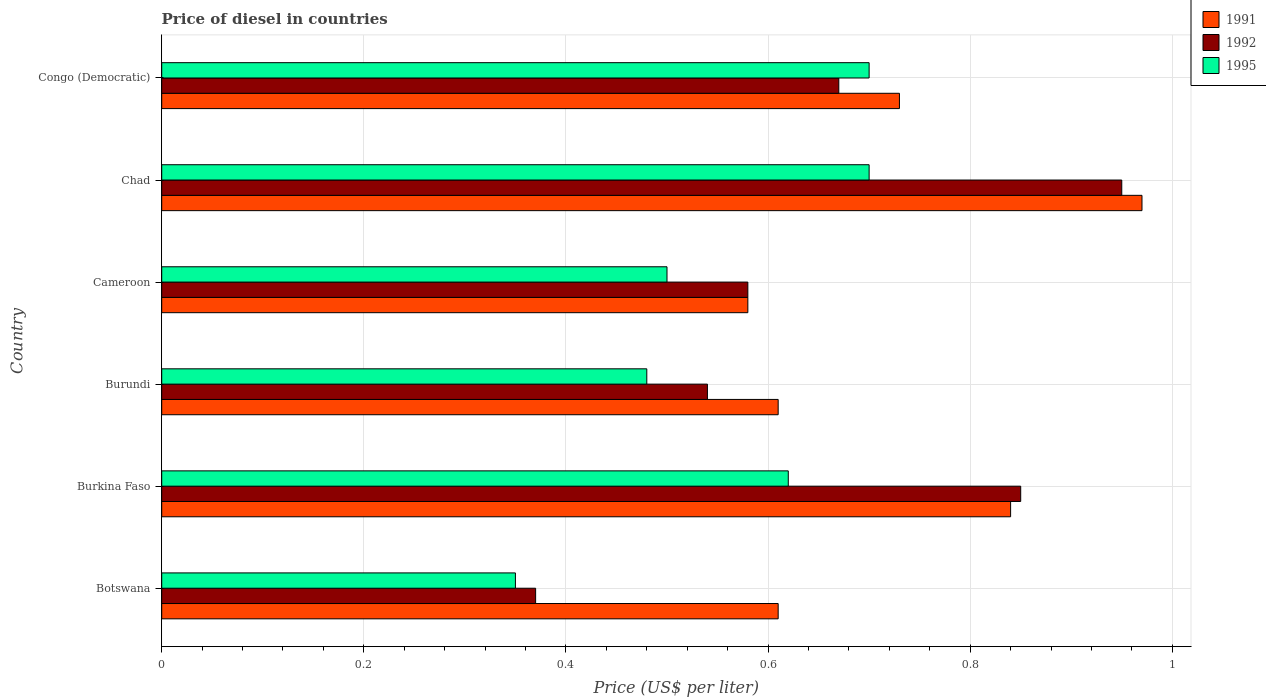How many different coloured bars are there?
Provide a succinct answer. 3. Are the number of bars per tick equal to the number of legend labels?
Provide a succinct answer. Yes. What is the label of the 2nd group of bars from the top?
Your answer should be compact. Chad. What is the price of diesel in 1995 in Burundi?
Provide a succinct answer. 0.48. Across all countries, what is the minimum price of diesel in 1991?
Make the answer very short. 0.58. In which country was the price of diesel in 1991 maximum?
Offer a terse response. Chad. In which country was the price of diesel in 1992 minimum?
Offer a very short reply. Botswana. What is the total price of diesel in 1991 in the graph?
Provide a short and direct response. 4.34. What is the difference between the price of diesel in 1991 in Burkina Faso and that in Burundi?
Make the answer very short. 0.23. What is the difference between the price of diesel in 1995 in Burkina Faso and the price of diesel in 1991 in Burundi?
Your answer should be compact. 0.01. What is the average price of diesel in 1992 per country?
Offer a very short reply. 0.66. What is the difference between the price of diesel in 1995 and price of diesel in 1992 in Chad?
Offer a terse response. -0.25. In how many countries, is the price of diesel in 1995 greater than 0.16 US$?
Your response must be concise. 6. What is the ratio of the price of diesel in 1995 in Burkina Faso to that in Chad?
Your answer should be compact. 0.89. What is the difference between the highest and the second highest price of diesel in 1992?
Your response must be concise. 0.1. What is the difference between the highest and the lowest price of diesel in 1992?
Your answer should be very brief. 0.58. In how many countries, is the price of diesel in 1992 greater than the average price of diesel in 1992 taken over all countries?
Offer a very short reply. 3. What does the 3rd bar from the top in Congo (Democratic) represents?
Provide a succinct answer. 1991. What does the 2nd bar from the bottom in Chad represents?
Offer a very short reply. 1992. Are the values on the major ticks of X-axis written in scientific E-notation?
Give a very brief answer. No. Does the graph contain grids?
Your response must be concise. Yes. How are the legend labels stacked?
Ensure brevity in your answer.  Vertical. What is the title of the graph?
Offer a terse response. Price of diesel in countries. What is the label or title of the X-axis?
Offer a terse response. Price (US$ per liter). What is the Price (US$ per liter) in 1991 in Botswana?
Your answer should be very brief. 0.61. What is the Price (US$ per liter) of 1992 in Botswana?
Make the answer very short. 0.37. What is the Price (US$ per liter) in 1995 in Botswana?
Offer a very short reply. 0.35. What is the Price (US$ per liter) in 1991 in Burkina Faso?
Offer a terse response. 0.84. What is the Price (US$ per liter) of 1995 in Burkina Faso?
Offer a terse response. 0.62. What is the Price (US$ per liter) in 1991 in Burundi?
Your answer should be compact. 0.61. What is the Price (US$ per liter) in 1992 in Burundi?
Make the answer very short. 0.54. What is the Price (US$ per liter) of 1995 in Burundi?
Offer a very short reply. 0.48. What is the Price (US$ per liter) of 1991 in Cameroon?
Your answer should be very brief. 0.58. What is the Price (US$ per liter) of 1992 in Cameroon?
Make the answer very short. 0.58. What is the Price (US$ per liter) of 1995 in Cameroon?
Your answer should be compact. 0.5. What is the Price (US$ per liter) of 1992 in Chad?
Offer a terse response. 0.95. What is the Price (US$ per liter) of 1991 in Congo (Democratic)?
Give a very brief answer. 0.73. What is the Price (US$ per liter) of 1992 in Congo (Democratic)?
Provide a succinct answer. 0.67. What is the Price (US$ per liter) of 1995 in Congo (Democratic)?
Make the answer very short. 0.7. Across all countries, what is the maximum Price (US$ per liter) in 1991?
Make the answer very short. 0.97. Across all countries, what is the maximum Price (US$ per liter) of 1992?
Keep it short and to the point. 0.95. Across all countries, what is the minimum Price (US$ per liter) of 1991?
Offer a very short reply. 0.58. Across all countries, what is the minimum Price (US$ per liter) of 1992?
Make the answer very short. 0.37. What is the total Price (US$ per liter) of 1991 in the graph?
Give a very brief answer. 4.34. What is the total Price (US$ per liter) of 1992 in the graph?
Offer a terse response. 3.96. What is the total Price (US$ per liter) in 1995 in the graph?
Your answer should be compact. 3.35. What is the difference between the Price (US$ per liter) in 1991 in Botswana and that in Burkina Faso?
Provide a succinct answer. -0.23. What is the difference between the Price (US$ per liter) of 1992 in Botswana and that in Burkina Faso?
Your response must be concise. -0.48. What is the difference between the Price (US$ per liter) of 1995 in Botswana and that in Burkina Faso?
Provide a short and direct response. -0.27. What is the difference between the Price (US$ per liter) in 1991 in Botswana and that in Burundi?
Offer a terse response. 0. What is the difference between the Price (US$ per liter) in 1992 in Botswana and that in Burundi?
Your answer should be very brief. -0.17. What is the difference between the Price (US$ per liter) of 1995 in Botswana and that in Burundi?
Your answer should be compact. -0.13. What is the difference between the Price (US$ per liter) of 1991 in Botswana and that in Cameroon?
Give a very brief answer. 0.03. What is the difference between the Price (US$ per liter) in 1992 in Botswana and that in Cameroon?
Offer a very short reply. -0.21. What is the difference between the Price (US$ per liter) in 1991 in Botswana and that in Chad?
Offer a very short reply. -0.36. What is the difference between the Price (US$ per liter) of 1992 in Botswana and that in Chad?
Ensure brevity in your answer.  -0.58. What is the difference between the Price (US$ per liter) of 1995 in Botswana and that in Chad?
Your answer should be compact. -0.35. What is the difference between the Price (US$ per liter) of 1991 in Botswana and that in Congo (Democratic)?
Your response must be concise. -0.12. What is the difference between the Price (US$ per liter) of 1995 in Botswana and that in Congo (Democratic)?
Your answer should be compact. -0.35. What is the difference between the Price (US$ per liter) of 1991 in Burkina Faso and that in Burundi?
Your answer should be very brief. 0.23. What is the difference between the Price (US$ per liter) in 1992 in Burkina Faso and that in Burundi?
Give a very brief answer. 0.31. What is the difference between the Price (US$ per liter) of 1995 in Burkina Faso and that in Burundi?
Make the answer very short. 0.14. What is the difference between the Price (US$ per liter) in 1991 in Burkina Faso and that in Cameroon?
Keep it short and to the point. 0.26. What is the difference between the Price (US$ per liter) of 1992 in Burkina Faso and that in Cameroon?
Provide a succinct answer. 0.27. What is the difference between the Price (US$ per liter) in 1995 in Burkina Faso and that in Cameroon?
Provide a succinct answer. 0.12. What is the difference between the Price (US$ per liter) in 1991 in Burkina Faso and that in Chad?
Give a very brief answer. -0.13. What is the difference between the Price (US$ per liter) in 1995 in Burkina Faso and that in Chad?
Provide a short and direct response. -0.08. What is the difference between the Price (US$ per liter) in 1991 in Burkina Faso and that in Congo (Democratic)?
Keep it short and to the point. 0.11. What is the difference between the Price (US$ per liter) in 1992 in Burkina Faso and that in Congo (Democratic)?
Provide a succinct answer. 0.18. What is the difference between the Price (US$ per liter) of 1995 in Burkina Faso and that in Congo (Democratic)?
Provide a succinct answer. -0.08. What is the difference between the Price (US$ per liter) of 1991 in Burundi and that in Cameroon?
Your answer should be very brief. 0.03. What is the difference between the Price (US$ per liter) in 1992 in Burundi and that in Cameroon?
Offer a terse response. -0.04. What is the difference between the Price (US$ per liter) in 1995 in Burundi and that in Cameroon?
Provide a short and direct response. -0.02. What is the difference between the Price (US$ per liter) in 1991 in Burundi and that in Chad?
Your response must be concise. -0.36. What is the difference between the Price (US$ per liter) in 1992 in Burundi and that in Chad?
Your answer should be compact. -0.41. What is the difference between the Price (US$ per liter) in 1995 in Burundi and that in Chad?
Provide a short and direct response. -0.22. What is the difference between the Price (US$ per liter) in 1991 in Burundi and that in Congo (Democratic)?
Offer a terse response. -0.12. What is the difference between the Price (US$ per liter) in 1992 in Burundi and that in Congo (Democratic)?
Ensure brevity in your answer.  -0.13. What is the difference between the Price (US$ per liter) of 1995 in Burundi and that in Congo (Democratic)?
Make the answer very short. -0.22. What is the difference between the Price (US$ per liter) of 1991 in Cameroon and that in Chad?
Make the answer very short. -0.39. What is the difference between the Price (US$ per liter) of 1992 in Cameroon and that in Chad?
Your answer should be very brief. -0.37. What is the difference between the Price (US$ per liter) in 1991 in Cameroon and that in Congo (Democratic)?
Make the answer very short. -0.15. What is the difference between the Price (US$ per liter) of 1992 in Cameroon and that in Congo (Democratic)?
Provide a succinct answer. -0.09. What is the difference between the Price (US$ per liter) in 1995 in Cameroon and that in Congo (Democratic)?
Provide a succinct answer. -0.2. What is the difference between the Price (US$ per liter) in 1991 in Chad and that in Congo (Democratic)?
Your answer should be compact. 0.24. What is the difference between the Price (US$ per liter) of 1992 in Chad and that in Congo (Democratic)?
Your answer should be very brief. 0.28. What is the difference between the Price (US$ per liter) in 1991 in Botswana and the Price (US$ per liter) in 1992 in Burkina Faso?
Offer a very short reply. -0.24. What is the difference between the Price (US$ per liter) in 1991 in Botswana and the Price (US$ per liter) in 1995 in Burkina Faso?
Give a very brief answer. -0.01. What is the difference between the Price (US$ per liter) of 1992 in Botswana and the Price (US$ per liter) of 1995 in Burkina Faso?
Provide a succinct answer. -0.25. What is the difference between the Price (US$ per liter) in 1991 in Botswana and the Price (US$ per liter) in 1992 in Burundi?
Ensure brevity in your answer.  0.07. What is the difference between the Price (US$ per liter) of 1991 in Botswana and the Price (US$ per liter) of 1995 in Burundi?
Your answer should be compact. 0.13. What is the difference between the Price (US$ per liter) of 1992 in Botswana and the Price (US$ per liter) of 1995 in Burundi?
Offer a very short reply. -0.11. What is the difference between the Price (US$ per liter) of 1991 in Botswana and the Price (US$ per liter) of 1992 in Cameroon?
Keep it short and to the point. 0.03. What is the difference between the Price (US$ per liter) of 1991 in Botswana and the Price (US$ per liter) of 1995 in Cameroon?
Make the answer very short. 0.11. What is the difference between the Price (US$ per liter) of 1992 in Botswana and the Price (US$ per liter) of 1995 in Cameroon?
Provide a short and direct response. -0.13. What is the difference between the Price (US$ per liter) in 1991 in Botswana and the Price (US$ per liter) in 1992 in Chad?
Ensure brevity in your answer.  -0.34. What is the difference between the Price (US$ per liter) of 1991 in Botswana and the Price (US$ per liter) of 1995 in Chad?
Your response must be concise. -0.09. What is the difference between the Price (US$ per liter) in 1992 in Botswana and the Price (US$ per liter) in 1995 in Chad?
Give a very brief answer. -0.33. What is the difference between the Price (US$ per liter) of 1991 in Botswana and the Price (US$ per liter) of 1992 in Congo (Democratic)?
Provide a succinct answer. -0.06. What is the difference between the Price (US$ per liter) of 1991 in Botswana and the Price (US$ per liter) of 1995 in Congo (Democratic)?
Offer a terse response. -0.09. What is the difference between the Price (US$ per liter) in 1992 in Botswana and the Price (US$ per liter) in 1995 in Congo (Democratic)?
Provide a succinct answer. -0.33. What is the difference between the Price (US$ per liter) of 1991 in Burkina Faso and the Price (US$ per liter) of 1992 in Burundi?
Offer a very short reply. 0.3. What is the difference between the Price (US$ per liter) of 1991 in Burkina Faso and the Price (US$ per liter) of 1995 in Burundi?
Offer a very short reply. 0.36. What is the difference between the Price (US$ per liter) in 1992 in Burkina Faso and the Price (US$ per liter) in 1995 in Burundi?
Ensure brevity in your answer.  0.37. What is the difference between the Price (US$ per liter) of 1991 in Burkina Faso and the Price (US$ per liter) of 1992 in Cameroon?
Keep it short and to the point. 0.26. What is the difference between the Price (US$ per liter) in 1991 in Burkina Faso and the Price (US$ per liter) in 1995 in Cameroon?
Keep it short and to the point. 0.34. What is the difference between the Price (US$ per liter) in 1992 in Burkina Faso and the Price (US$ per liter) in 1995 in Cameroon?
Provide a succinct answer. 0.35. What is the difference between the Price (US$ per liter) in 1991 in Burkina Faso and the Price (US$ per liter) in 1992 in Chad?
Make the answer very short. -0.11. What is the difference between the Price (US$ per liter) in 1991 in Burkina Faso and the Price (US$ per liter) in 1995 in Chad?
Provide a short and direct response. 0.14. What is the difference between the Price (US$ per liter) in 1992 in Burkina Faso and the Price (US$ per liter) in 1995 in Chad?
Provide a short and direct response. 0.15. What is the difference between the Price (US$ per liter) of 1991 in Burkina Faso and the Price (US$ per liter) of 1992 in Congo (Democratic)?
Give a very brief answer. 0.17. What is the difference between the Price (US$ per liter) in 1991 in Burkina Faso and the Price (US$ per liter) in 1995 in Congo (Democratic)?
Ensure brevity in your answer.  0.14. What is the difference between the Price (US$ per liter) in 1992 in Burkina Faso and the Price (US$ per liter) in 1995 in Congo (Democratic)?
Your answer should be compact. 0.15. What is the difference between the Price (US$ per liter) of 1991 in Burundi and the Price (US$ per liter) of 1995 in Cameroon?
Offer a very short reply. 0.11. What is the difference between the Price (US$ per liter) in 1991 in Burundi and the Price (US$ per liter) in 1992 in Chad?
Keep it short and to the point. -0.34. What is the difference between the Price (US$ per liter) in 1991 in Burundi and the Price (US$ per liter) in 1995 in Chad?
Keep it short and to the point. -0.09. What is the difference between the Price (US$ per liter) of 1992 in Burundi and the Price (US$ per liter) of 1995 in Chad?
Provide a short and direct response. -0.16. What is the difference between the Price (US$ per liter) in 1991 in Burundi and the Price (US$ per liter) in 1992 in Congo (Democratic)?
Ensure brevity in your answer.  -0.06. What is the difference between the Price (US$ per liter) in 1991 in Burundi and the Price (US$ per liter) in 1995 in Congo (Democratic)?
Your response must be concise. -0.09. What is the difference between the Price (US$ per liter) of 1992 in Burundi and the Price (US$ per liter) of 1995 in Congo (Democratic)?
Provide a succinct answer. -0.16. What is the difference between the Price (US$ per liter) of 1991 in Cameroon and the Price (US$ per liter) of 1992 in Chad?
Offer a very short reply. -0.37. What is the difference between the Price (US$ per liter) in 1991 in Cameroon and the Price (US$ per liter) in 1995 in Chad?
Offer a very short reply. -0.12. What is the difference between the Price (US$ per liter) of 1992 in Cameroon and the Price (US$ per liter) of 1995 in Chad?
Provide a short and direct response. -0.12. What is the difference between the Price (US$ per liter) of 1991 in Cameroon and the Price (US$ per liter) of 1992 in Congo (Democratic)?
Keep it short and to the point. -0.09. What is the difference between the Price (US$ per liter) in 1991 in Cameroon and the Price (US$ per liter) in 1995 in Congo (Democratic)?
Your answer should be very brief. -0.12. What is the difference between the Price (US$ per liter) of 1992 in Cameroon and the Price (US$ per liter) of 1995 in Congo (Democratic)?
Your response must be concise. -0.12. What is the difference between the Price (US$ per liter) in 1991 in Chad and the Price (US$ per liter) in 1992 in Congo (Democratic)?
Provide a succinct answer. 0.3. What is the difference between the Price (US$ per liter) of 1991 in Chad and the Price (US$ per liter) of 1995 in Congo (Democratic)?
Offer a very short reply. 0.27. What is the difference between the Price (US$ per liter) in 1992 in Chad and the Price (US$ per liter) in 1995 in Congo (Democratic)?
Ensure brevity in your answer.  0.25. What is the average Price (US$ per liter) of 1991 per country?
Keep it short and to the point. 0.72. What is the average Price (US$ per liter) in 1992 per country?
Your answer should be compact. 0.66. What is the average Price (US$ per liter) in 1995 per country?
Offer a very short reply. 0.56. What is the difference between the Price (US$ per liter) in 1991 and Price (US$ per liter) in 1992 in Botswana?
Ensure brevity in your answer.  0.24. What is the difference between the Price (US$ per liter) of 1991 and Price (US$ per liter) of 1995 in Botswana?
Make the answer very short. 0.26. What is the difference between the Price (US$ per liter) of 1992 and Price (US$ per liter) of 1995 in Botswana?
Offer a terse response. 0.02. What is the difference between the Price (US$ per liter) of 1991 and Price (US$ per liter) of 1992 in Burkina Faso?
Your answer should be compact. -0.01. What is the difference between the Price (US$ per liter) of 1991 and Price (US$ per liter) of 1995 in Burkina Faso?
Ensure brevity in your answer.  0.22. What is the difference between the Price (US$ per liter) in 1992 and Price (US$ per liter) in 1995 in Burkina Faso?
Your answer should be compact. 0.23. What is the difference between the Price (US$ per liter) of 1991 and Price (US$ per liter) of 1992 in Burundi?
Make the answer very short. 0.07. What is the difference between the Price (US$ per liter) in 1991 and Price (US$ per liter) in 1995 in Burundi?
Your answer should be compact. 0.13. What is the difference between the Price (US$ per liter) of 1992 and Price (US$ per liter) of 1995 in Burundi?
Your response must be concise. 0.06. What is the difference between the Price (US$ per liter) of 1991 and Price (US$ per liter) of 1992 in Cameroon?
Ensure brevity in your answer.  0. What is the difference between the Price (US$ per liter) in 1991 and Price (US$ per liter) in 1995 in Cameroon?
Give a very brief answer. 0.08. What is the difference between the Price (US$ per liter) in 1992 and Price (US$ per liter) in 1995 in Cameroon?
Offer a very short reply. 0.08. What is the difference between the Price (US$ per liter) in 1991 and Price (US$ per liter) in 1992 in Chad?
Offer a very short reply. 0.02. What is the difference between the Price (US$ per liter) of 1991 and Price (US$ per liter) of 1995 in Chad?
Make the answer very short. 0.27. What is the difference between the Price (US$ per liter) of 1991 and Price (US$ per liter) of 1992 in Congo (Democratic)?
Your answer should be very brief. 0.06. What is the difference between the Price (US$ per liter) of 1992 and Price (US$ per liter) of 1995 in Congo (Democratic)?
Offer a terse response. -0.03. What is the ratio of the Price (US$ per liter) of 1991 in Botswana to that in Burkina Faso?
Give a very brief answer. 0.73. What is the ratio of the Price (US$ per liter) in 1992 in Botswana to that in Burkina Faso?
Offer a terse response. 0.44. What is the ratio of the Price (US$ per liter) of 1995 in Botswana to that in Burkina Faso?
Provide a short and direct response. 0.56. What is the ratio of the Price (US$ per liter) in 1991 in Botswana to that in Burundi?
Keep it short and to the point. 1. What is the ratio of the Price (US$ per liter) of 1992 in Botswana to that in Burundi?
Your response must be concise. 0.69. What is the ratio of the Price (US$ per liter) of 1995 in Botswana to that in Burundi?
Ensure brevity in your answer.  0.73. What is the ratio of the Price (US$ per liter) of 1991 in Botswana to that in Cameroon?
Provide a succinct answer. 1.05. What is the ratio of the Price (US$ per liter) of 1992 in Botswana to that in Cameroon?
Offer a terse response. 0.64. What is the ratio of the Price (US$ per liter) in 1991 in Botswana to that in Chad?
Give a very brief answer. 0.63. What is the ratio of the Price (US$ per liter) of 1992 in Botswana to that in Chad?
Provide a succinct answer. 0.39. What is the ratio of the Price (US$ per liter) in 1995 in Botswana to that in Chad?
Offer a terse response. 0.5. What is the ratio of the Price (US$ per liter) in 1991 in Botswana to that in Congo (Democratic)?
Make the answer very short. 0.84. What is the ratio of the Price (US$ per liter) in 1992 in Botswana to that in Congo (Democratic)?
Keep it short and to the point. 0.55. What is the ratio of the Price (US$ per liter) of 1995 in Botswana to that in Congo (Democratic)?
Your answer should be very brief. 0.5. What is the ratio of the Price (US$ per liter) in 1991 in Burkina Faso to that in Burundi?
Provide a succinct answer. 1.38. What is the ratio of the Price (US$ per liter) of 1992 in Burkina Faso to that in Burundi?
Make the answer very short. 1.57. What is the ratio of the Price (US$ per liter) of 1995 in Burkina Faso to that in Burundi?
Keep it short and to the point. 1.29. What is the ratio of the Price (US$ per liter) of 1991 in Burkina Faso to that in Cameroon?
Provide a succinct answer. 1.45. What is the ratio of the Price (US$ per liter) in 1992 in Burkina Faso to that in Cameroon?
Ensure brevity in your answer.  1.47. What is the ratio of the Price (US$ per liter) in 1995 in Burkina Faso to that in Cameroon?
Provide a short and direct response. 1.24. What is the ratio of the Price (US$ per liter) in 1991 in Burkina Faso to that in Chad?
Your answer should be compact. 0.87. What is the ratio of the Price (US$ per liter) in 1992 in Burkina Faso to that in Chad?
Provide a short and direct response. 0.89. What is the ratio of the Price (US$ per liter) of 1995 in Burkina Faso to that in Chad?
Provide a short and direct response. 0.89. What is the ratio of the Price (US$ per liter) in 1991 in Burkina Faso to that in Congo (Democratic)?
Offer a very short reply. 1.15. What is the ratio of the Price (US$ per liter) in 1992 in Burkina Faso to that in Congo (Democratic)?
Provide a short and direct response. 1.27. What is the ratio of the Price (US$ per liter) in 1995 in Burkina Faso to that in Congo (Democratic)?
Provide a short and direct response. 0.89. What is the ratio of the Price (US$ per liter) in 1991 in Burundi to that in Cameroon?
Your answer should be compact. 1.05. What is the ratio of the Price (US$ per liter) in 1991 in Burundi to that in Chad?
Offer a terse response. 0.63. What is the ratio of the Price (US$ per liter) in 1992 in Burundi to that in Chad?
Provide a short and direct response. 0.57. What is the ratio of the Price (US$ per liter) of 1995 in Burundi to that in Chad?
Your answer should be compact. 0.69. What is the ratio of the Price (US$ per liter) in 1991 in Burundi to that in Congo (Democratic)?
Your response must be concise. 0.84. What is the ratio of the Price (US$ per liter) in 1992 in Burundi to that in Congo (Democratic)?
Give a very brief answer. 0.81. What is the ratio of the Price (US$ per liter) in 1995 in Burundi to that in Congo (Democratic)?
Your answer should be compact. 0.69. What is the ratio of the Price (US$ per liter) in 1991 in Cameroon to that in Chad?
Ensure brevity in your answer.  0.6. What is the ratio of the Price (US$ per liter) of 1992 in Cameroon to that in Chad?
Your response must be concise. 0.61. What is the ratio of the Price (US$ per liter) in 1995 in Cameroon to that in Chad?
Provide a succinct answer. 0.71. What is the ratio of the Price (US$ per liter) of 1991 in Cameroon to that in Congo (Democratic)?
Your answer should be very brief. 0.79. What is the ratio of the Price (US$ per liter) in 1992 in Cameroon to that in Congo (Democratic)?
Give a very brief answer. 0.87. What is the ratio of the Price (US$ per liter) in 1995 in Cameroon to that in Congo (Democratic)?
Provide a succinct answer. 0.71. What is the ratio of the Price (US$ per liter) in 1991 in Chad to that in Congo (Democratic)?
Make the answer very short. 1.33. What is the ratio of the Price (US$ per liter) in 1992 in Chad to that in Congo (Democratic)?
Make the answer very short. 1.42. What is the difference between the highest and the second highest Price (US$ per liter) in 1991?
Your answer should be very brief. 0.13. What is the difference between the highest and the second highest Price (US$ per liter) in 1992?
Your answer should be compact. 0.1. What is the difference between the highest and the lowest Price (US$ per liter) in 1991?
Ensure brevity in your answer.  0.39. What is the difference between the highest and the lowest Price (US$ per liter) in 1992?
Offer a very short reply. 0.58. 